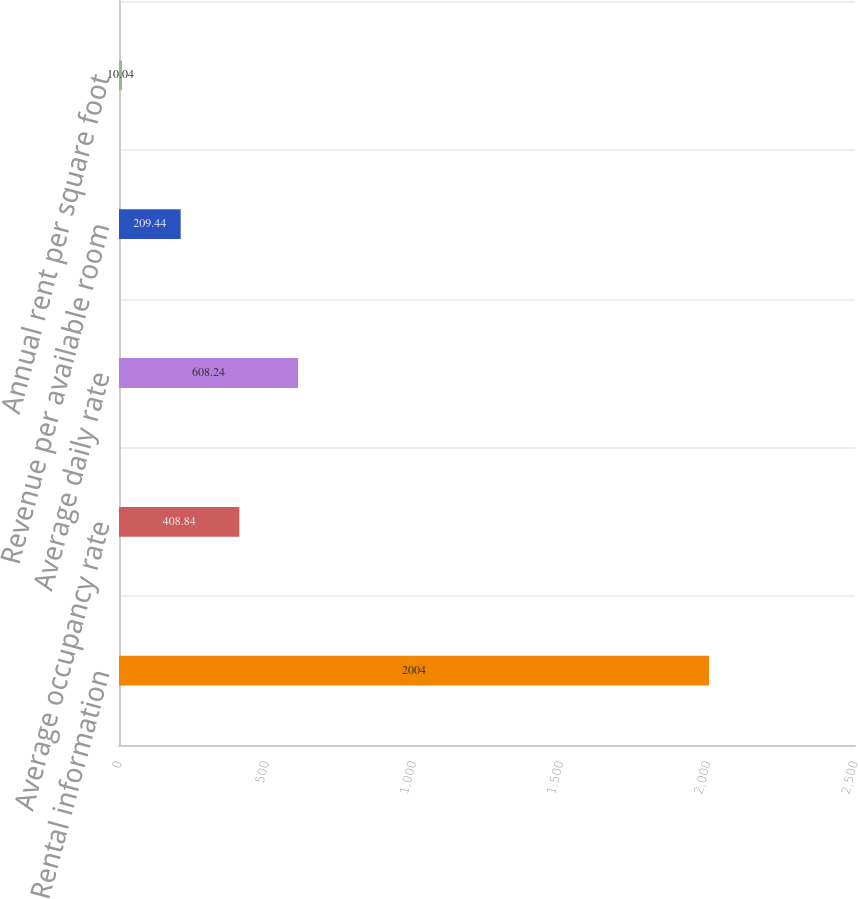Convert chart. <chart><loc_0><loc_0><loc_500><loc_500><bar_chart><fcel>Rental information<fcel>Average occupancy rate<fcel>Average daily rate<fcel>Revenue per available room<fcel>Annual rent per square foot<nl><fcel>2004<fcel>408.84<fcel>608.24<fcel>209.44<fcel>10.04<nl></chart> 